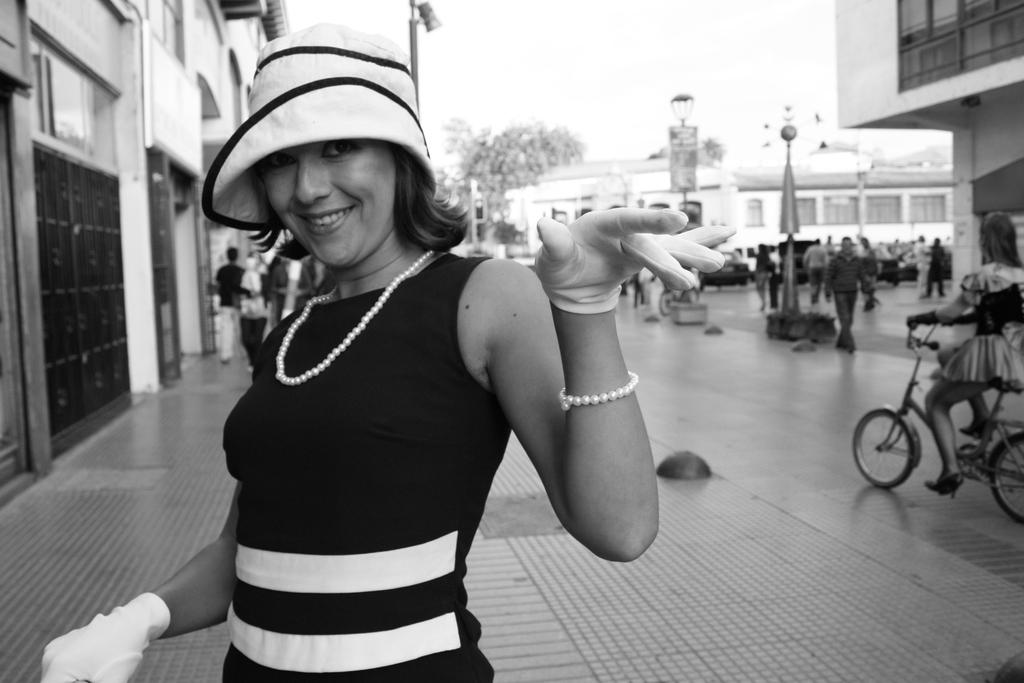What is the woman on the left side of the image doing? The woman on the left side of the image is smiling. What can be seen in the background of the image? There are buildings, trees, and poles in the background of the image. Are there any other people visible in the image? Yes, there are people in the background of the image. What is the woman on the right side of the image doing? The woman on the right side of the image is riding a bicycle. What is the woman's opinion on the cloud in the image? There is no cloud visible in the image, so it is not possible to determine the woman's opinion on a cloud. 